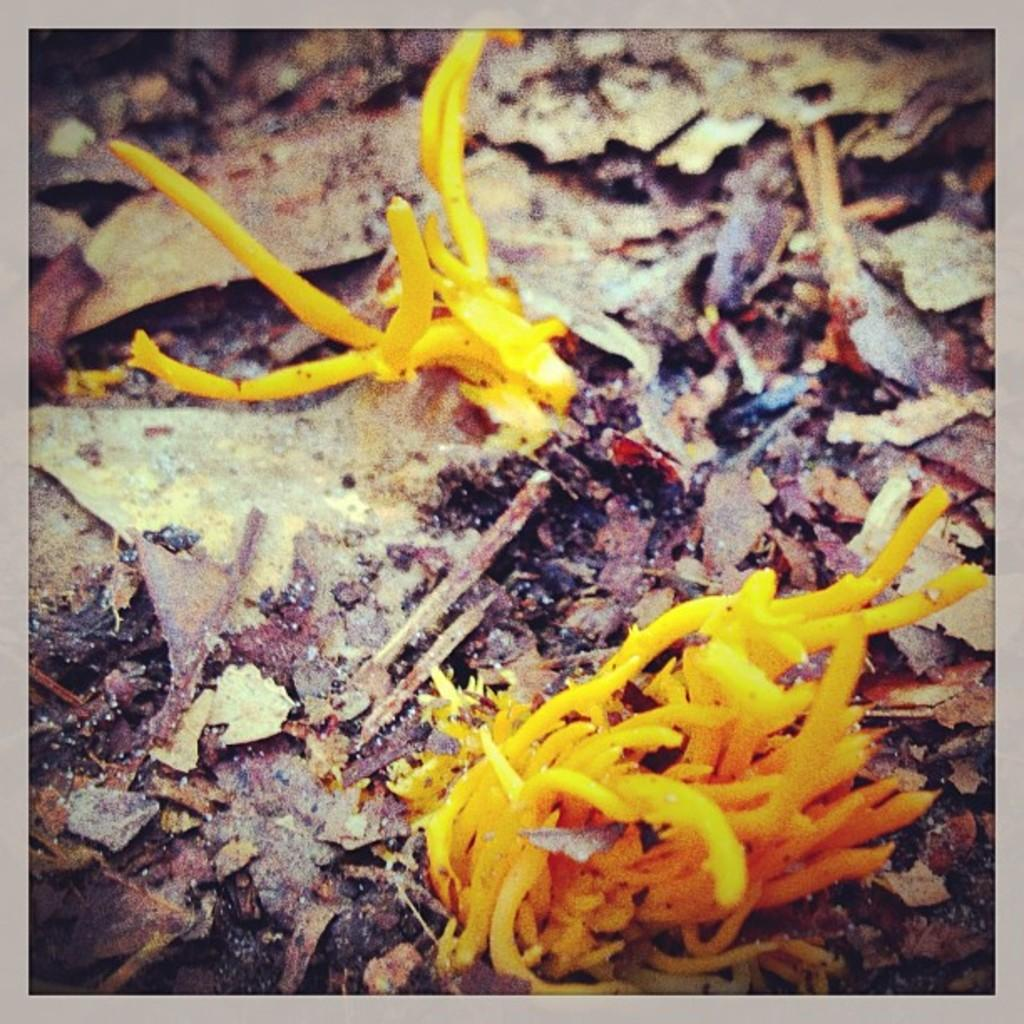What is present at the bottom of the image? There are leaves at the bottom of the image. What can be seen in the front of the image? There is a plant in the front of the image. What type of alarm is ringing in the image? There is no alarm present in the image. What kind of toothpaste is used to clean the plant in the image? There is no toothpaste mentioned or implied in the image; plants are typically not cleaned with toothpaste. 